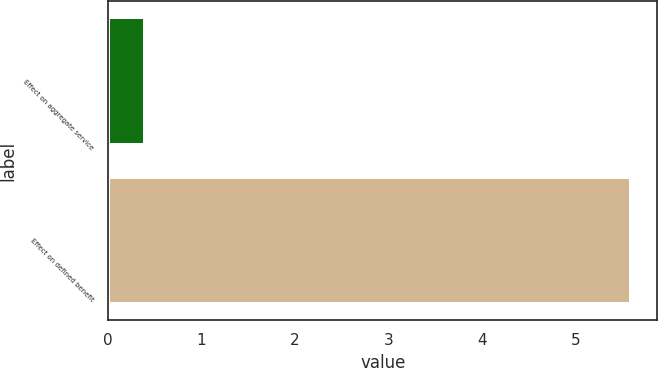Convert chart to OTSL. <chart><loc_0><loc_0><loc_500><loc_500><bar_chart><fcel>Effect on aggregate service<fcel>Effect on defined benefit<nl><fcel>0.4<fcel>5.6<nl></chart> 